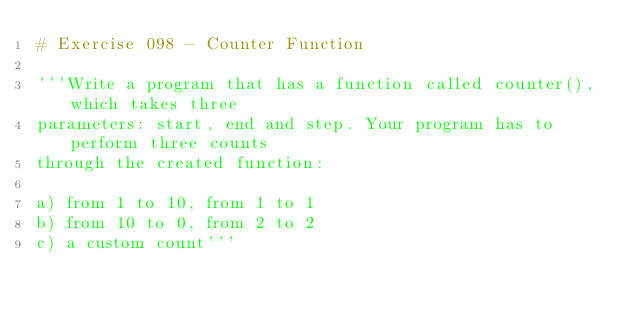Convert code to text. <code><loc_0><loc_0><loc_500><loc_500><_Python_># Exercise 098 - Counter Function

'''Write a program that has a function called counter(), which takes three 
parameters: start, end and step. Your program has to perform three counts 
through the created function:

a) from 1 to 10, from 1 to 1
b) from 10 to 0, from 2 to 2
c) a custom count'''
</code> 